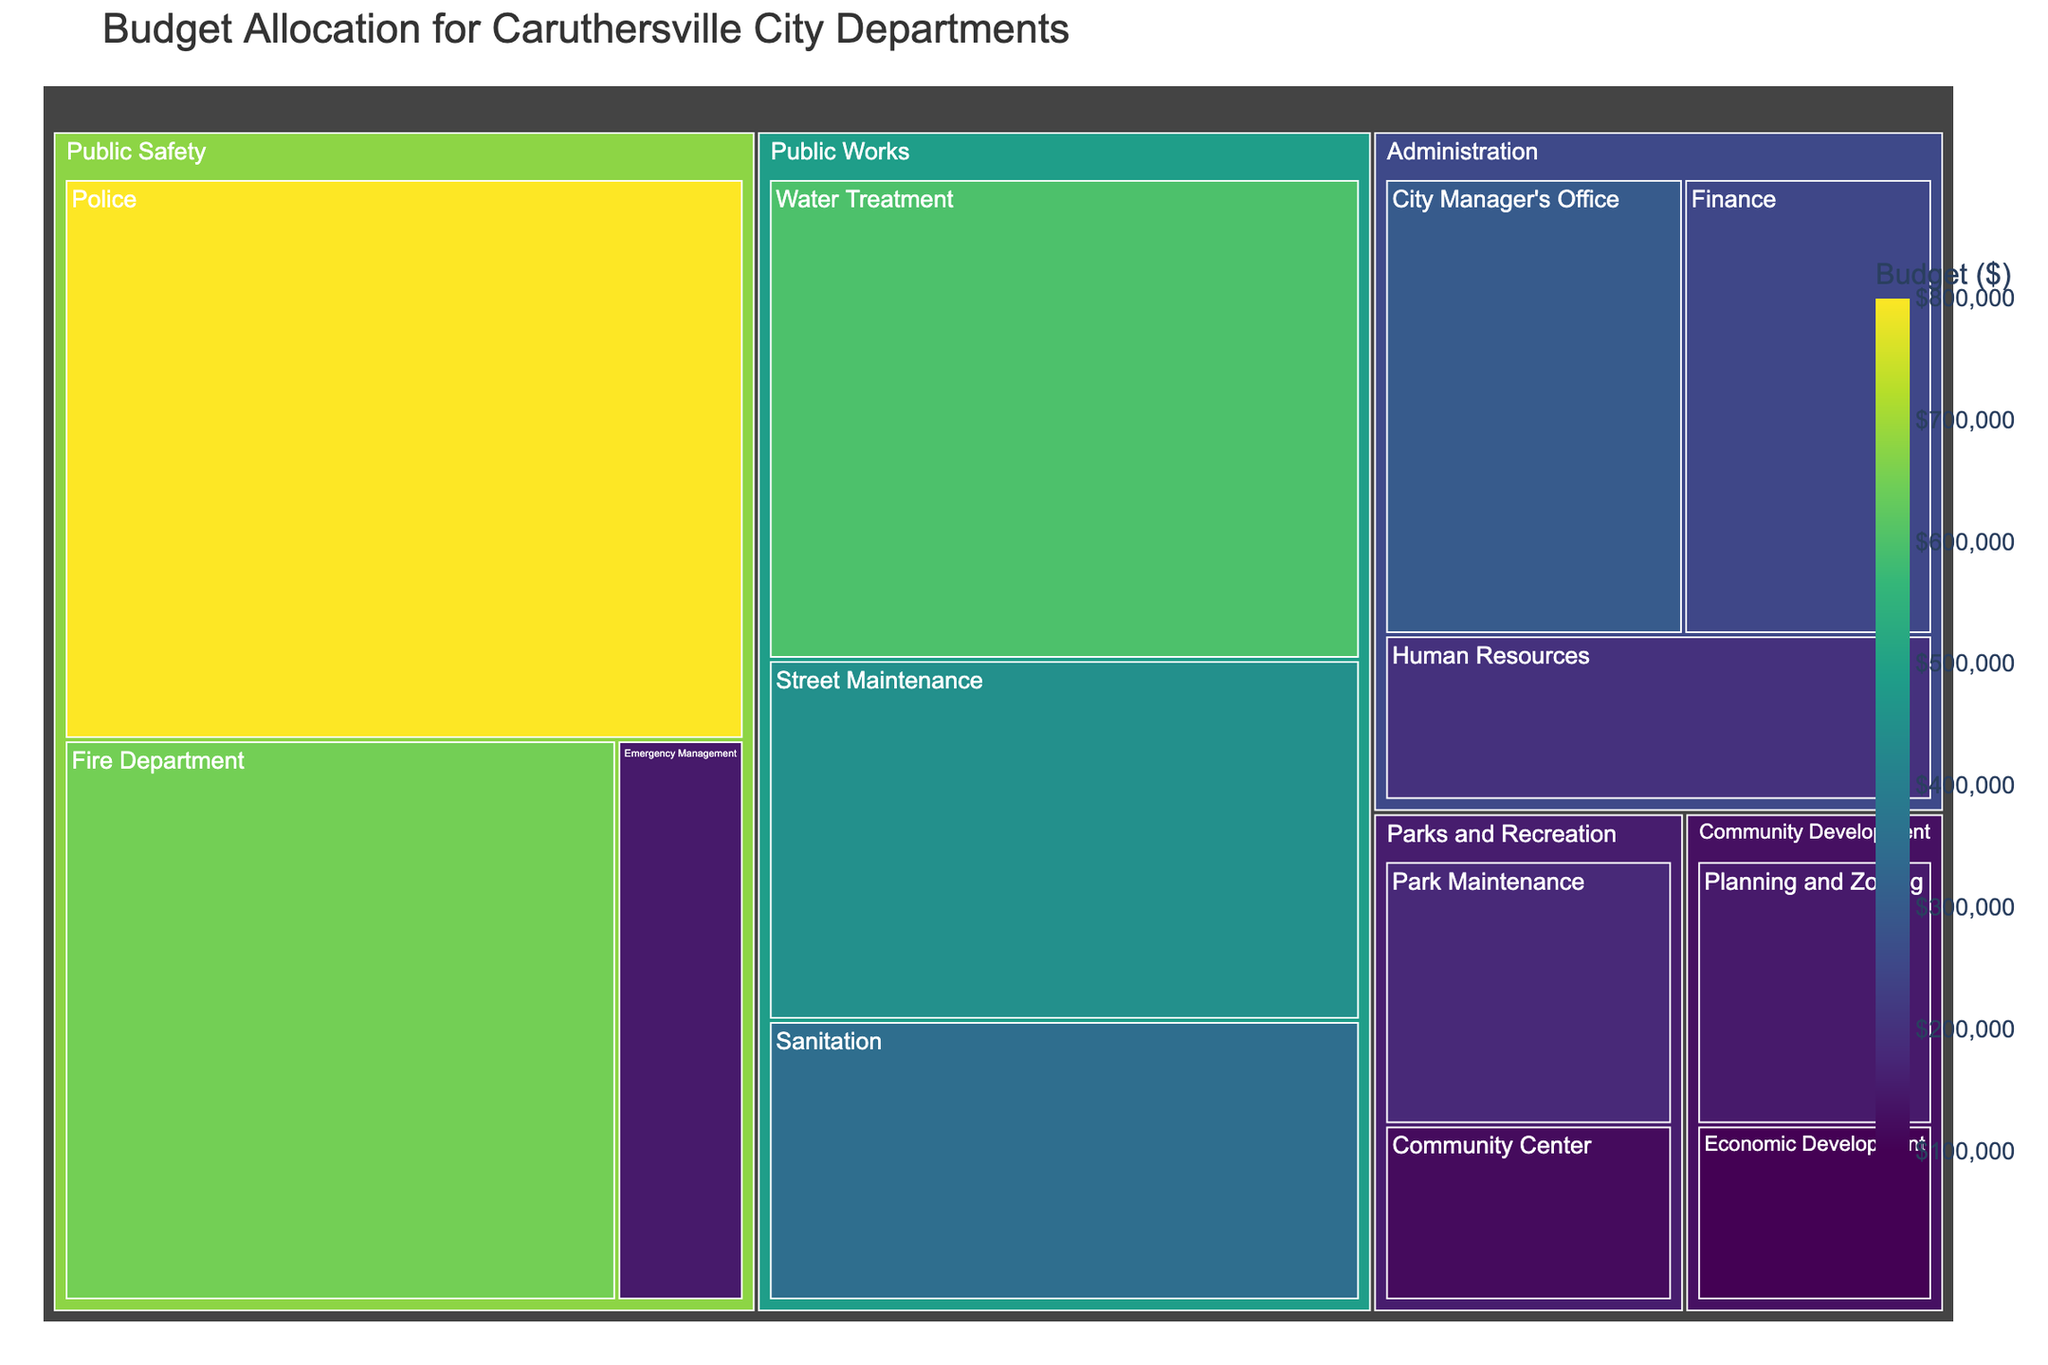What is the title of the Treemap? The title is located at the top of the Treemap. It is typically larger in size and often bolded to stand out from other text elements.
Answer: Budget Allocation for Caruthersville City Departments Which department has the largest total budget allocation? To find this, we need to add up the budgets for each category within each department. Here, the department with the highest aggregated budget amount reveals the answer.
Answer: Public Safety What is the total budget for the Public Works department? Add up the budgets for all categories under Public Works: Street Maintenance (450,000) + Sanitation (350,000) + Water Treatment (600,000).
Answer: 1,400,000 What is the budget allocated for the Finance category under Administration? Locate the Finance category under the Administration department in the Treemap. The budget for each category is shown as part of the hover data.
Answer: 250,000 Compare the budget for Street Maintenance with that of the Fire Department. Which one is higher? Identify the budgets for Street Maintenance (450,000) and the Fire Department (650,000). Compare these two values to determine which is higher.
Answer: Fire Department What percentage of the total budget is allocated to the Police? The budget for the Police is 800,000. The total budget is the sum of all individual categories. Calculate the percentage by dividing the Police budget by the total budget and then multiplying by 100.
Answer: Roughly 21.5% How does the budget for Parks and Recreation compare to Community Development? Sum the budgets for categories under each department and compare: Parks and Recreation (180,000 + 120,000) vs. Community Development (150,000 + 100,000).
Answer: Parks and Recreation has a higher budget Is the budget for Emergency Management larger than it is for Planning and Zoning? Compare the budget for Emergency Management (150,000) directly with the budget for Planning and Zoning (150,000).
Answer: No, they are equal What is the difference between the budgets for the Sanitation category and the Human Resources category? Subtract the budget for Human Resources (200,000) from the budget for Sanitation (350,000).
Answer: 150,000 What is the smallest budget assigned to any category within the Treemap? Locate the category with the smallest budget value, as indicated in the hover data.
Answer: Economic Development (100,000) 